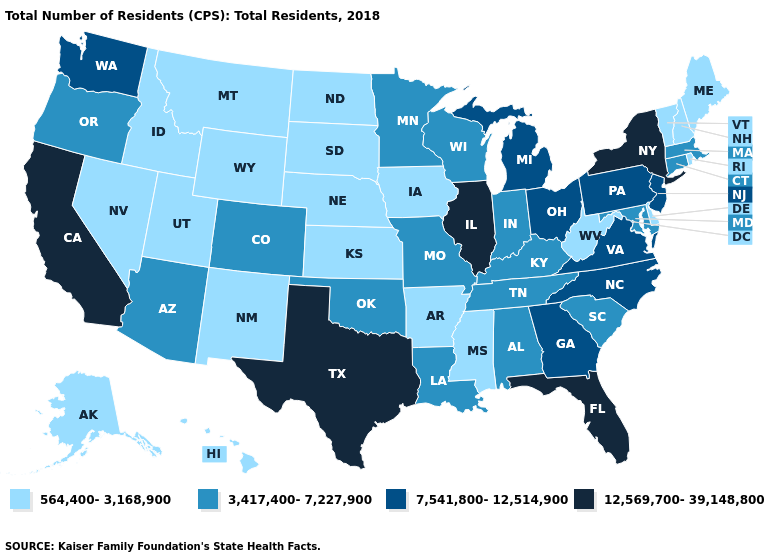Name the states that have a value in the range 564,400-3,168,900?
Be succinct. Alaska, Arkansas, Delaware, Hawaii, Idaho, Iowa, Kansas, Maine, Mississippi, Montana, Nebraska, Nevada, New Hampshire, New Mexico, North Dakota, Rhode Island, South Dakota, Utah, Vermont, West Virginia, Wyoming. Among the states that border Alabama , does Mississippi have the lowest value?
Concise answer only. Yes. Name the states that have a value in the range 3,417,400-7,227,900?
Be succinct. Alabama, Arizona, Colorado, Connecticut, Indiana, Kentucky, Louisiana, Maryland, Massachusetts, Minnesota, Missouri, Oklahoma, Oregon, South Carolina, Tennessee, Wisconsin. What is the value of New Mexico?
Keep it brief. 564,400-3,168,900. Does Florida have the highest value in the South?
Give a very brief answer. Yes. Which states have the lowest value in the South?
Keep it brief. Arkansas, Delaware, Mississippi, West Virginia. What is the highest value in the USA?
Quick response, please. 12,569,700-39,148,800. How many symbols are there in the legend?
Answer briefly. 4. Does Hawaii have the highest value in the West?
Write a very short answer. No. Does Oklahoma have the same value as Arizona?
Give a very brief answer. Yes. Name the states that have a value in the range 564,400-3,168,900?
Quick response, please. Alaska, Arkansas, Delaware, Hawaii, Idaho, Iowa, Kansas, Maine, Mississippi, Montana, Nebraska, Nevada, New Hampshire, New Mexico, North Dakota, Rhode Island, South Dakota, Utah, Vermont, West Virginia, Wyoming. Does Illinois have the highest value in the USA?
Give a very brief answer. Yes. Name the states that have a value in the range 12,569,700-39,148,800?
Keep it brief. California, Florida, Illinois, New York, Texas. What is the value of California?
Give a very brief answer. 12,569,700-39,148,800. Name the states that have a value in the range 7,541,800-12,514,900?
Be succinct. Georgia, Michigan, New Jersey, North Carolina, Ohio, Pennsylvania, Virginia, Washington. 